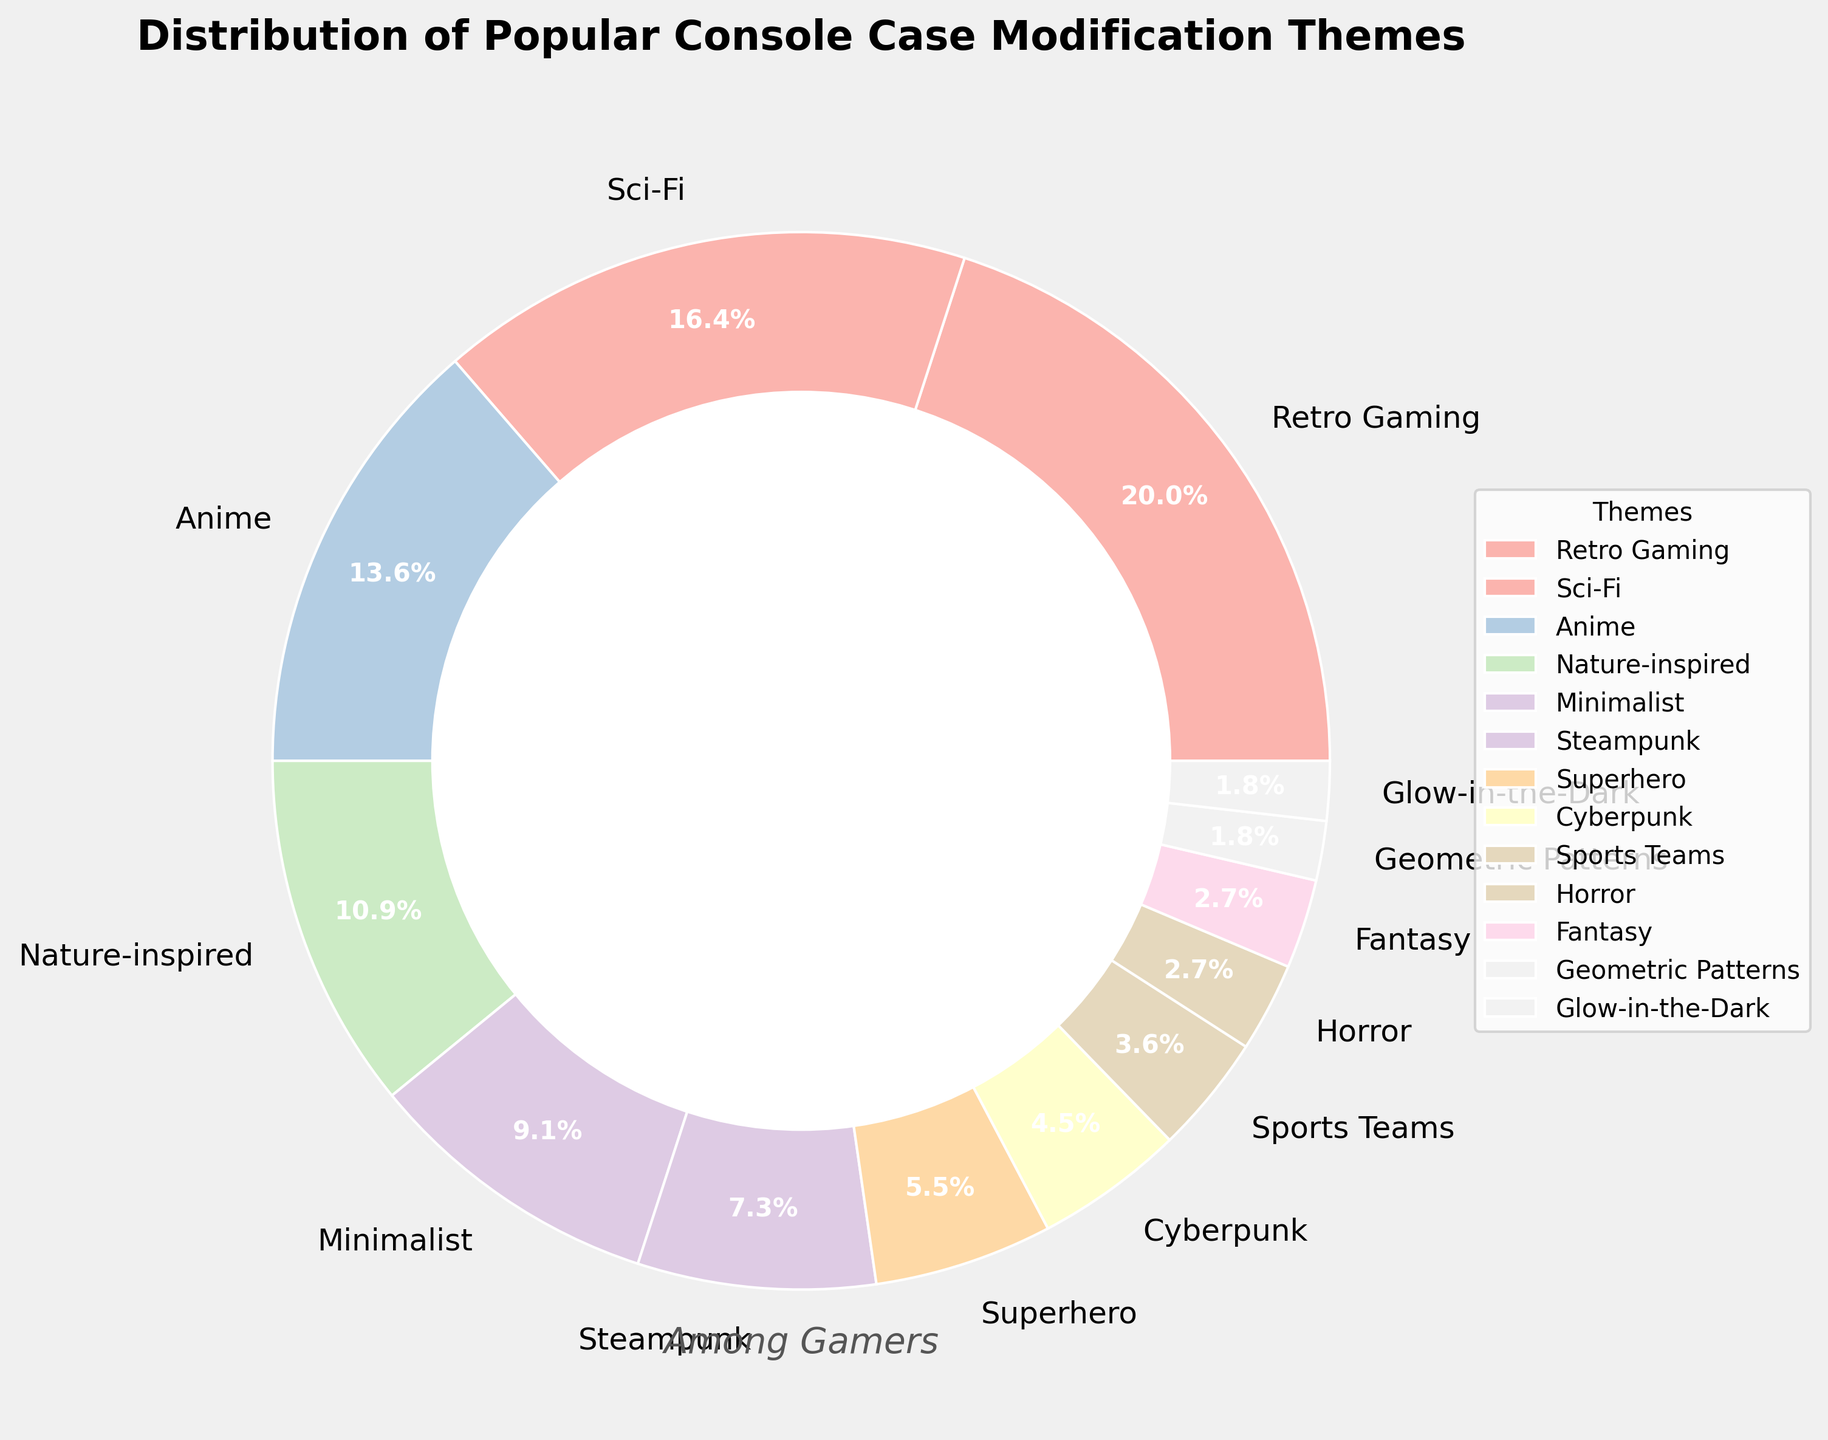What theme has the highest percentage among gamers? The theme with the largest slice in the pie chart represents the highest percentage among gamers. In this case, the Retro Gaming slice is the largest.
Answer: Retro Gaming How much higher is the percentage of Retro Gaming compared to Cyberpunk? To find out how much higher the percentage of Retro Gaming is compared to Cyberpunk, subtract the percentage of Cyberpunk from Retro Gaming. Retro Gaming is 22% and Cyberpunk is 5%, so 22 - 5 = 17%.
Answer: 17% What three themes combined have the largest share? The three largest slices will give us the themes with the highest combined percentage. Retro Gaming (22%), Sci-Fi (18%), and Anime (15%) are the three largest slices. Their combined percentage is 22 + 18 + 15 = 55%.
Answer: Retro Gaming, Sci-Fi, Anime What is the percentage difference between the highest and lowest theme percentages? Subtract the percentage of the smallest theme slice (Geometric Patterns or Glow-in-the-Dark at 2%) from the largest theme slice (Retro Gaming at 22%). So, 22 - 2 = 20%.
Answer: 20% Which theme has the smallest percentage and what is the value? Look for the slice with the smallest percentage. Both Geometric Patterns and Glow-in-the-Dark have the smallest slices with 2%.
Answer: Geometric Patterns and Glow-in-the-Dark, 2% Is the percentage of the Minimalist theme greater than that of the Nature-inspired theme? Compare the slices labeled Minimalist (10%) and Nature-inspired (12%). Since 10% is less than 12%, Minimalist is not greater than Nature-inspired.
Answer: No What is the combined percentage of the Fantasy and Horror themes? Add the percentages of Fantasy (3%) and Horror (3%) together. So, 3 + 3 = 6%.
Answer: 6% How do the percentage shares of Superhero and Cyberpunk themes compare? Compare the slices labeled Superhero (6%) and Cyberpunk (5%). Since 6% is greater than 5%, Superhero has a higher percentage share than Cyberpunk.
Answer: Superhero is higher What is the total percentage of themes that have a share of less than 10%? Add the percentages of all themes with less than 10%: Steampunk (8%), Superhero (6%), Cyberpunk (5%), Sports Teams (4%), Horror (3%), Fantasy (3%), Geometric Patterns (2%), Glow-in-the-Dark (2%). So, 8 + 6 + 5 + 4 + 3 + 3 + 2 + 2 = 33%.
Answer: 33% What is the visual style used for the pie chart background? The description notes that the figure has a background with a facecolor of '#F0F0F0', which looks like a light grey color.
Answer: Light grey 